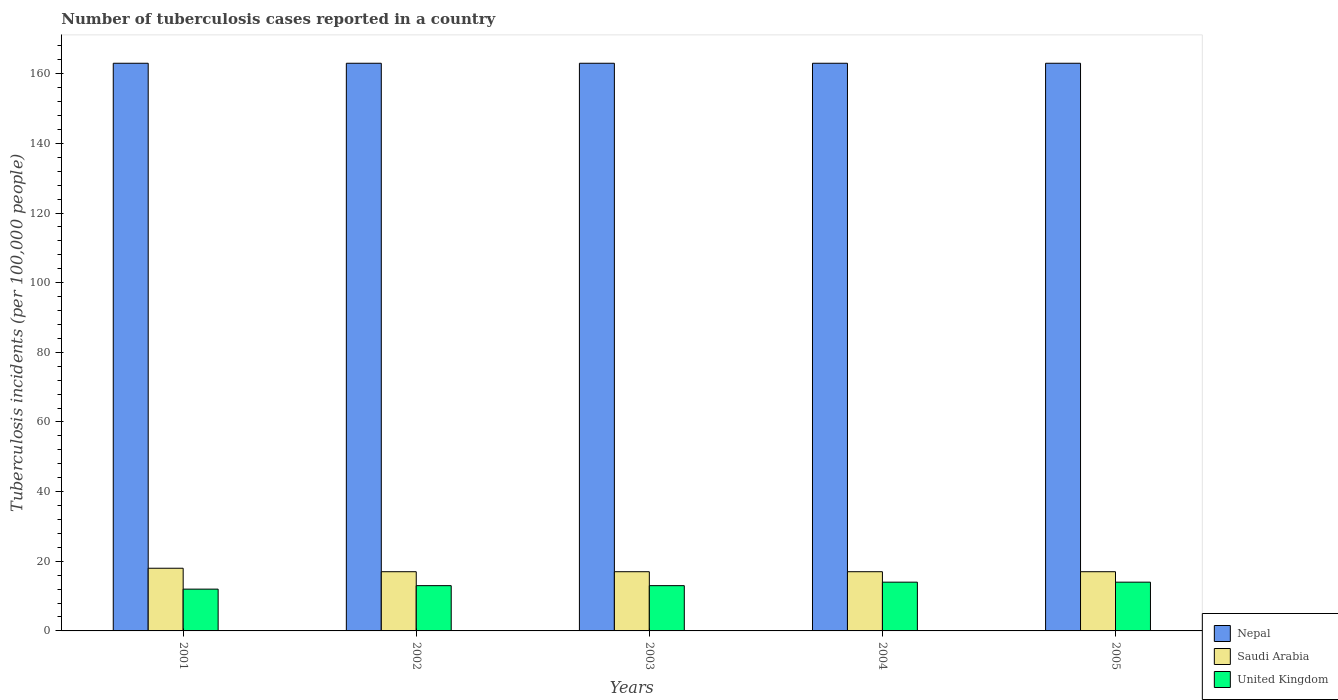Are the number of bars per tick equal to the number of legend labels?
Your response must be concise. Yes. Are the number of bars on each tick of the X-axis equal?
Keep it short and to the point. Yes. How many bars are there on the 5th tick from the left?
Ensure brevity in your answer.  3. What is the label of the 5th group of bars from the left?
Your answer should be very brief. 2005. What is the number of tuberculosis cases reported in in Nepal in 2002?
Keep it short and to the point. 163. Across all years, what is the maximum number of tuberculosis cases reported in in United Kingdom?
Provide a short and direct response. 14. Across all years, what is the minimum number of tuberculosis cases reported in in Saudi Arabia?
Make the answer very short. 17. In which year was the number of tuberculosis cases reported in in United Kingdom minimum?
Offer a very short reply. 2001. What is the total number of tuberculosis cases reported in in Saudi Arabia in the graph?
Keep it short and to the point. 86. What is the difference between the number of tuberculosis cases reported in in Nepal in 2002 and that in 2005?
Offer a very short reply. 0. What is the difference between the number of tuberculosis cases reported in in United Kingdom in 2005 and the number of tuberculosis cases reported in in Nepal in 2001?
Ensure brevity in your answer.  -149. In the year 2002, what is the difference between the number of tuberculosis cases reported in in Saudi Arabia and number of tuberculosis cases reported in in United Kingdom?
Offer a terse response. 4. What is the ratio of the number of tuberculosis cases reported in in Nepal in 2002 to that in 2005?
Your response must be concise. 1. What is the difference between the highest and the lowest number of tuberculosis cases reported in in Saudi Arabia?
Keep it short and to the point. 1. In how many years, is the number of tuberculosis cases reported in in United Kingdom greater than the average number of tuberculosis cases reported in in United Kingdom taken over all years?
Ensure brevity in your answer.  2. What does the 1st bar from the left in 2003 represents?
Give a very brief answer. Nepal. What does the 2nd bar from the right in 2004 represents?
Keep it short and to the point. Saudi Arabia. Is it the case that in every year, the sum of the number of tuberculosis cases reported in in Saudi Arabia and number of tuberculosis cases reported in in Nepal is greater than the number of tuberculosis cases reported in in United Kingdom?
Give a very brief answer. Yes. How many bars are there?
Your answer should be compact. 15. Are all the bars in the graph horizontal?
Offer a terse response. No. How many years are there in the graph?
Give a very brief answer. 5. What is the difference between two consecutive major ticks on the Y-axis?
Give a very brief answer. 20. Are the values on the major ticks of Y-axis written in scientific E-notation?
Ensure brevity in your answer.  No. Does the graph contain grids?
Your response must be concise. No. How many legend labels are there?
Offer a terse response. 3. What is the title of the graph?
Make the answer very short. Number of tuberculosis cases reported in a country. What is the label or title of the X-axis?
Make the answer very short. Years. What is the label or title of the Y-axis?
Offer a terse response. Tuberculosis incidents (per 100,0 people). What is the Tuberculosis incidents (per 100,000 people) of Nepal in 2001?
Give a very brief answer. 163. What is the Tuberculosis incidents (per 100,000 people) of United Kingdom in 2001?
Keep it short and to the point. 12. What is the Tuberculosis incidents (per 100,000 people) in Nepal in 2002?
Provide a short and direct response. 163. What is the Tuberculosis incidents (per 100,000 people) of Saudi Arabia in 2002?
Make the answer very short. 17. What is the Tuberculosis incidents (per 100,000 people) of United Kingdom in 2002?
Make the answer very short. 13. What is the Tuberculosis incidents (per 100,000 people) in Nepal in 2003?
Your answer should be compact. 163. What is the Tuberculosis incidents (per 100,000 people) of Saudi Arabia in 2003?
Your answer should be compact. 17. What is the Tuberculosis incidents (per 100,000 people) of United Kingdom in 2003?
Your response must be concise. 13. What is the Tuberculosis incidents (per 100,000 people) in Nepal in 2004?
Provide a short and direct response. 163. What is the Tuberculosis incidents (per 100,000 people) in United Kingdom in 2004?
Ensure brevity in your answer.  14. What is the Tuberculosis incidents (per 100,000 people) in Nepal in 2005?
Make the answer very short. 163. What is the Tuberculosis incidents (per 100,000 people) in Saudi Arabia in 2005?
Keep it short and to the point. 17. What is the Tuberculosis incidents (per 100,000 people) of United Kingdom in 2005?
Make the answer very short. 14. Across all years, what is the maximum Tuberculosis incidents (per 100,000 people) in Nepal?
Offer a terse response. 163. Across all years, what is the maximum Tuberculosis incidents (per 100,000 people) of Saudi Arabia?
Make the answer very short. 18. Across all years, what is the minimum Tuberculosis incidents (per 100,000 people) in Nepal?
Provide a succinct answer. 163. What is the total Tuberculosis incidents (per 100,000 people) in Nepal in the graph?
Your response must be concise. 815. What is the total Tuberculosis incidents (per 100,000 people) in Saudi Arabia in the graph?
Provide a succinct answer. 86. What is the total Tuberculosis incidents (per 100,000 people) in United Kingdom in the graph?
Ensure brevity in your answer.  66. What is the difference between the Tuberculosis incidents (per 100,000 people) of Nepal in 2001 and that in 2003?
Offer a terse response. 0. What is the difference between the Tuberculosis incidents (per 100,000 people) of Saudi Arabia in 2001 and that in 2003?
Offer a very short reply. 1. What is the difference between the Tuberculosis incidents (per 100,000 people) in United Kingdom in 2001 and that in 2003?
Your response must be concise. -1. What is the difference between the Tuberculosis incidents (per 100,000 people) in United Kingdom in 2001 and that in 2004?
Keep it short and to the point. -2. What is the difference between the Tuberculosis incidents (per 100,000 people) in United Kingdom in 2001 and that in 2005?
Make the answer very short. -2. What is the difference between the Tuberculosis incidents (per 100,000 people) in Nepal in 2002 and that in 2003?
Your answer should be compact. 0. What is the difference between the Tuberculosis incidents (per 100,000 people) of United Kingdom in 2002 and that in 2003?
Your answer should be compact. 0. What is the difference between the Tuberculosis incidents (per 100,000 people) of Nepal in 2002 and that in 2005?
Your answer should be compact. 0. What is the difference between the Tuberculosis incidents (per 100,000 people) in Nepal in 2003 and that in 2004?
Provide a short and direct response. 0. What is the difference between the Tuberculosis incidents (per 100,000 people) of Saudi Arabia in 2003 and that in 2004?
Offer a terse response. 0. What is the difference between the Tuberculosis incidents (per 100,000 people) of United Kingdom in 2003 and that in 2004?
Ensure brevity in your answer.  -1. What is the difference between the Tuberculosis incidents (per 100,000 people) of Nepal in 2003 and that in 2005?
Give a very brief answer. 0. What is the difference between the Tuberculosis incidents (per 100,000 people) of Saudi Arabia in 2004 and that in 2005?
Give a very brief answer. 0. What is the difference between the Tuberculosis incidents (per 100,000 people) of United Kingdom in 2004 and that in 2005?
Your response must be concise. 0. What is the difference between the Tuberculosis incidents (per 100,000 people) of Nepal in 2001 and the Tuberculosis incidents (per 100,000 people) of Saudi Arabia in 2002?
Offer a very short reply. 146. What is the difference between the Tuberculosis incidents (per 100,000 people) in Nepal in 2001 and the Tuberculosis incidents (per 100,000 people) in United Kingdom in 2002?
Your response must be concise. 150. What is the difference between the Tuberculosis incidents (per 100,000 people) of Nepal in 2001 and the Tuberculosis incidents (per 100,000 people) of Saudi Arabia in 2003?
Your answer should be compact. 146. What is the difference between the Tuberculosis incidents (per 100,000 people) of Nepal in 2001 and the Tuberculosis incidents (per 100,000 people) of United Kingdom in 2003?
Ensure brevity in your answer.  150. What is the difference between the Tuberculosis incidents (per 100,000 people) of Nepal in 2001 and the Tuberculosis incidents (per 100,000 people) of Saudi Arabia in 2004?
Provide a succinct answer. 146. What is the difference between the Tuberculosis incidents (per 100,000 people) of Nepal in 2001 and the Tuberculosis incidents (per 100,000 people) of United Kingdom in 2004?
Offer a terse response. 149. What is the difference between the Tuberculosis incidents (per 100,000 people) in Saudi Arabia in 2001 and the Tuberculosis incidents (per 100,000 people) in United Kingdom in 2004?
Give a very brief answer. 4. What is the difference between the Tuberculosis incidents (per 100,000 people) in Nepal in 2001 and the Tuberculosis incidents (per 100,000 people) in Saudi Arabia in 2005?
Make the answer very short. 146. What is the difference between the Tuberculosis incidents (per 100,000 people) of Nepal in 2001 and the Tuberculosis incidents (per 100,000 people) of United Kingdom in 2005?
Offer a very short reply. 149. What is the difference between the Tuberculosis incidents (per 100,000 people) in Nepal in 2002 and the Tuberculosis incidents (per 100,000 people) in Saudi Arabia in 2003?
Offer a very short reply. 146. What is the difference between the Tuberculosis incidents (per 100,000 people) in Nepal in 2002 and the Tuberculosis incidents (per 100,000 people) in United Kingdom in 2003?
Offer a very short reply. 150. What is the difference between the Tuberculosis incidents (per 100,000 people) of Saudi Arabia in 2002 and the Tuberculosis incidents (per 100,000 people) of United Kingdom in 2003?
Provide a short and direct response. 4. What is the difference between the Tuberculosis incidents (per 100,000 people) in Nepal in 2002 and the Tuberculosis incidents (per 100,000 people) in Saudi Arabia in 2004?
Make the answer very short. 146. What is the difference between the Tuberculosis incidents (per 100,000 people) in Nepal in 2002 and the Tuberculosis incidents (per 100,000 people) in United Kingdom in 2004?
Offer a terse response. 149. What is the difference between the Tuberculosis incidents (per 100,000 people) of Nepal in 2002 and the Tuberculosis incidents (per 100,000 people) of Saudi Arabia in 2005?
Ensure brevity in your answer.  146. What is the difference between the Tuberculosis incidents (per 100,000 people) of Nepal in 2002 and the Tuberculosis incidents (per 100,000 people) of United Kingdom in 2005?
Offer a very short reply. 149. What is the difference between the Tuberculosis incidents (per 100,000 people) of Saudi Arabia in 2002 and the Tuberculosis incidents (per 100,000 people) of United Kingdom in 2005?
Your answer should be compact. 3. What is the difference between the Tuberculosis incidents (per 100,000 people) in Nepal in 2003 and the Tuberculosis incidents (per 100,000 people) in Saudi Arabia in 2004?
Your answer should be very brief. 146. What is the difference between the Tuberculosis incidents (per 100,000 people) of Nepal in 2003 and the Tuberculosis incidents (per 100,000 people) of United Kingdom in 2004?
Keep it short and to the point. 149. What is the difference between the Tuberculosis incidents (per 100,000 people) of Nepal in 2003 and the Tuberculosis incidents (per 100,000 people) of Saudi Arabia in 2005?
Provide a succinct answer. 146. What is the difference between the Tuberculosis incidents (per 100,000 people) in Nepal in 2003 and the Tuberculosis incidents (per 100,000 people) in United Kingdom in 2005?
Offer a terse response. 149. What is the difference between the Tuberculosis incidents (per 100,000 people) of Saudi Arabia in 2003 and the Tuberculosis incidents (per 100,000 people) of United Kingdom in 2005?
Your response must be concise. 3. What is the difference between the Tuberculosis incidents (per 100,000 people) of Nepal in 2004 and the Tuberculosis incidents (per 100,000 people) of Saudi Arabia in 2005?
Keep it short and to the point. 146. What is the difference between the Tuberculosis incidents (per 100,000 people) of Nepal in 2004 and the Tuberculosis incidents (per 100,000 people) of United Kingdom in 2005?
Give a very brief answer. 149. What is the difference between the Tuberculosis incidents (per 100,000 people) of Saudi Arabia in 2004 and the Tuberculosis incidents (per 100,000 people) of United Kingdom in 2005?
Keep it short and to the point. 3. What is the average Tuberculosis incidents (per 100,000 people) of Nepal per year?
Keep it short and to the point. 163. What is the average Tuberculosis incidents (per 100,000 people) in Saudi Arabia per year?
Provide a succinct answer. 17.2. What is the average Tuberculosis incidents (per 100,000 people) in United Kingdom per year?
Provide a short and direct response. 13.2. In the year 2001, what is the difference between the Tuberculosis incidents (per 100,000 people) of Nepal and Tuberculosis incidents (per 100,000 people) of Saudi Arabia?
Offer a very short reply. 145. In the year 2001, what is the difference between the Tuberculosis incidents (per 100,000 people) of Nepal and Tuberculosis incidents (per 100,000 people) of United Kingdom?
Keep it short and to the point. 151. In the year 2002, what is the difference between the Tuberculosis incidents (per 100,000 people) in Nepal and Tuberculosis incidents (per 100,000 people) in Saudi Arabia?
Your answer should be very brief. 146. In the year 2002, what is the difference between the Tuberculosis incidents (per 100,000 people) of Nepal and Tuberculosis incidents (per 100,000 people) of United Kingdom?
Provide a succinct answer. 150. In the year 2002, what is the difference between the Tuberculosis incidents (per 100,000 people) of Saudi Arabia and Tuberculosis incidents (per 100,000 people) of United Kingdom?
Provide a short and direct response. 4. In the year 2003, what is the difference between the Tuberculosis incidents (per 100,000 people) of Nepal and Tuberculosis incidents (per 100,000 people) of Saudi Arabia?
Your answer should be compact. 146. In the year 2003, what is the difference between the Tuberculosis incidents (per 100,000 people) in Nepal and Tuberculosis incidents (per 100,000 people) in United Kingdom?
Make the answer very short. 150. In the year 2004, what is the difference between the Tuberculosis incidents (per 100,000 people) in Nepal and Tuberculosis incidents (per 100,000 people) in Saudi Arabia?
Keep it short and to the point. 146. In the year 2004, what is the difference between the Tuberculosis incidents (per 100,000 people) in Nepal and Tuberculosis incidents (per 100,000 people) in United Kingdom?
Offer a terse response. 149. In the year 2004, what is the difference between the Tuberculosis incidents (per 100,000 people) in Saudi Arabia and Tuberculosis incidents (per 100,000 people) in United Kingdom?
Offer a very short reply. 3. In the year 2005, what is the difference between the Tuberculosis incidents (per 100,000 people) in Nepal and Tuberculosis incidents (per 100,000 people) in Saudi Arabia?
Make the answer very short. 146. In the year 2005, what is the difference between the Tuberculosis incidents (per 100,000 people) of Nepal and Tuberculosis incidents (per 100,000 people) of United Kingdom?
Provide a succinct answer. 149. In the year 2005, what is the difference between the Tuberculosis incidents (per 100,000 people) of Saudi Arabia and Tuberculosis incidents (per 100,000 people) of United Kingdom?
Keep it short and to the point. 3. What is the ratio of the Tuberculosis incidents (per 100,000 people) of Saudi Arabia in 2001 to that in 2002?
Keep it short and to the point. 1.06. What is the ratio of the Tuberculosis incidents (per 100,000 people) in United Kingdom in 2001 to that in 2002?
Give a very brief answer. 0.92. What is the ratio of the Tuberculosis incidents (per 100,000 people) of Saudi Arabia in 2001 to that in 2003?
Offer a terse response. 1.06. What is the ratio of the Tuberculosis incidents (per 100,000 people) in United Kingdom in 2001 to that in 2003?
Offer a terse response. 0.92. What is the ratio of the Tuberculosis incidents (per 100,000 people) of Saudi Arabia in 2001 to that in 2004?
Your answer should be very brief. 1.06. What is the ratio of the Tuberculosis incidents (per 100,000 people) in United Kingdom in 2001 to that in 2004?
Your answer should be compact. 0.86. What is the ratio of the Tuberculosis incidents (per 100,000 people) of Nepal in 2001 to that in 2005?
Make the answer very short. 1. What is the ratio of the Tuberculosis incidents (per 100,000 people) in Saudi Arabia in 2001 to that in 2005?
Offer a very short reply. 1.06. What is the ratio of the Tuberculosis incidents (per 100,000 people) of Nepal in 2002 to that in 2003?
Your answer should be very brief. 1. What is the ratio of the Tuberculosis incidents (per 100,000 people) of Saudi Arabia in 2002 to that in 2003?
Provide a short and direct response. 1. What is the ratio of the Tuberculosis incidents (per 100,000 people) of United Kingdom in 2002 to that in 2003?
Ensure brevity in your answer.  1. What is the ratio of the Tuberculosis incidents (per 100,000 people) of Nepal in 2002 to that in 2005?
Keep it short and to the point. 1. What is the ratio of the Tuberculosis incidents (per 100,000 people) in Saudi Arabia in 2002 to that in 2005?
Your answer should be very brief. 1. What is the ratio of the Tuberculosis incidents (per 100,000 people) in United Kingdom in 2002 to that in 2005?
Make the answer very short. 0.93. What is the ratio of the Tuberculosis incidents (per 100,000 people) in Nepal in 2003 to that in 2004?
Offer a very short reply. 1. What is the ratio of the Tuberculosis incidents (per 100,000 people) in Saudi Arabia in 2003 to that in 2005?
Provide a succinct answer. 1. What is the ratio of the Tuberculosis incidents (per 100,000 people) in United Kingdom in 2003 to that in 2005?
Make the answer very short. 0.93. What is the ratio of the Tuberculosis incidents (per 100,000 people) of United Kingdom in 2004 to that in 2005?
Provide a short and direct response. 1. What is the difference between the highest and the second highest Tuberculosis incidents (per 100,000 people) of Nepal?
Ensure brevity in your answer.  0. What is the difference between the highest and the second highest Tuberculosis incidents (per 100,000 people) in Saudi Arabia?
Provide a short and direct response. 1. What is the difference between the highest and the lowest Tuberculosis incidents (per 100,000 people) in Nepal?
Provide a succinct answer. 0. What is the difference between the highest and the lowest Tuberculosis incidents (per 100,000 people) of Saudi Arabia?
Your response must be concise. 1. What is the difference between the highest and the lowest Tuberculosis incidents (per 100,000 people) in United Kingdom?
Offer a very short reply. 2. 